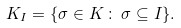<formula> <loc_0><loc_0><loc_500><loc_500>K _ { I } = \{ \sigma \in K \, \colon \, \sigma \subseteq I \} .</formula> 